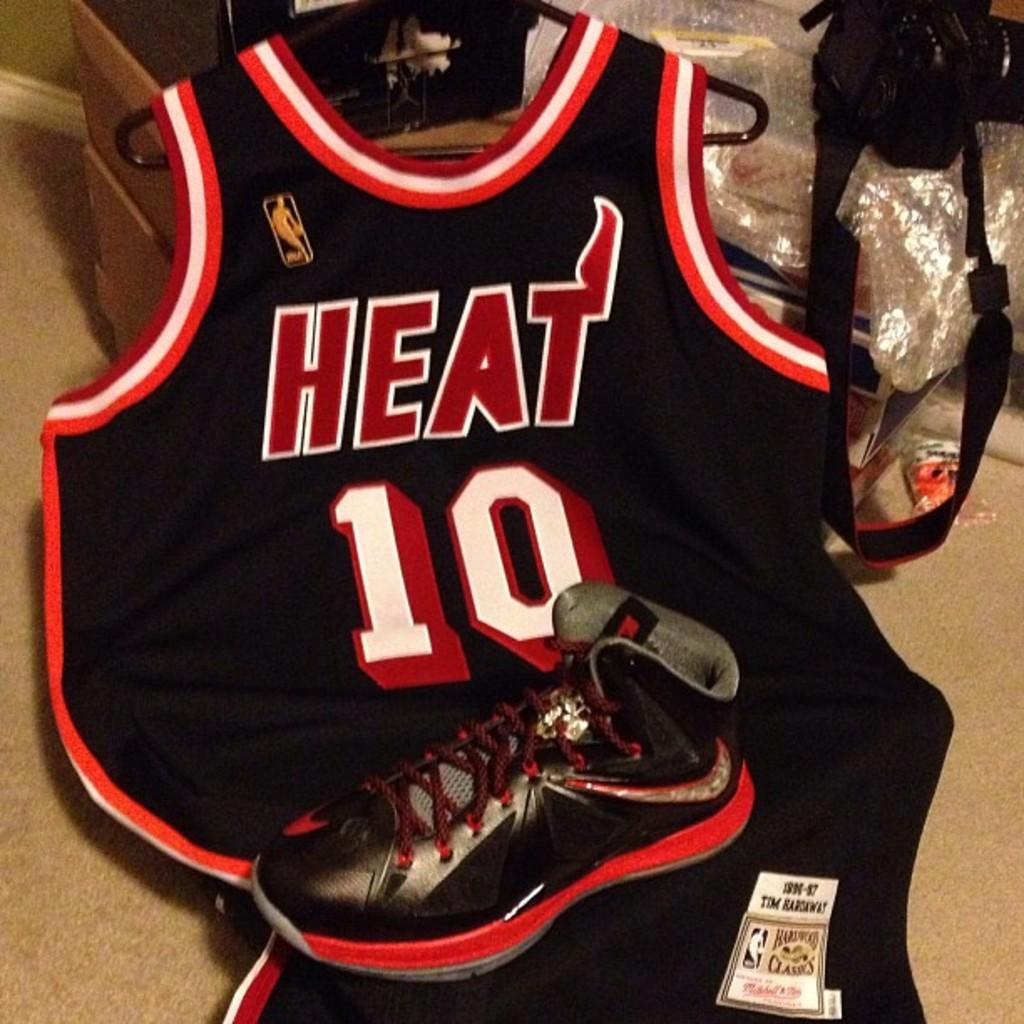<image>
Render a clear and concise summary of the photo. A heat jersey under a shoe has the number 10 on it. 